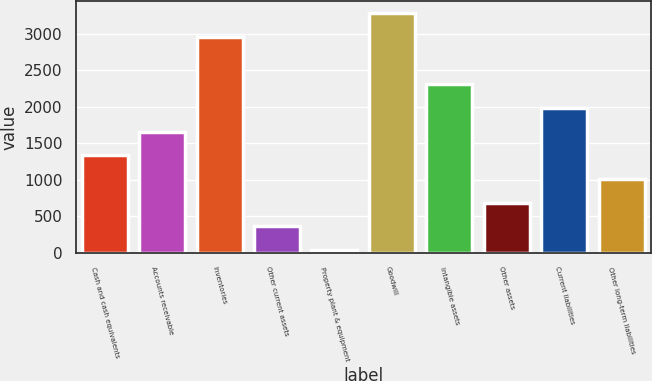Convert chart to OTSL. <chart><loc_0><loc_0><loc_500><loc_500><bar_chart><fcel>Cash and cash equivalents<fcel>Accounts receivable<fcel>Inventories<fcel>Other current assets<fcel>Property plant & equipment<fcel>Goodwill<fcel>Intangible assets<fcel>Other assets<fcel>Current liabilities<fcel>Other long-term liabilities<nl><fcel>1336<fcel>1661<fcel>2961<fcel>361<fcel>36<fcel>3286<fcel>2311<fcel>686<fcel>1986<fcel>1011<nl></chart> 